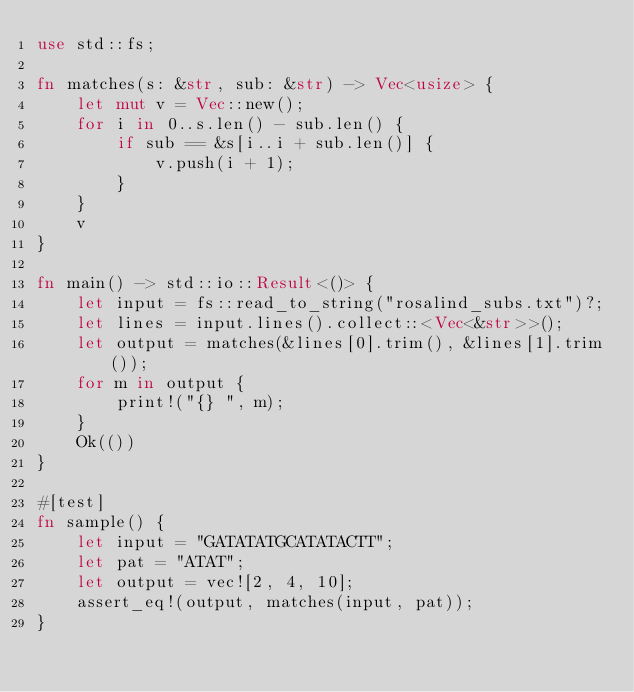<code> <loc_0><loc_0><loc_500><loc_500><_Rust_>use std::fs;

fn matches(s: &str, sub: &str) -> Vec<usize> {
    let mut v = Vec::new();
    for i in 0..s.len() - sub.len() {
        if sub == &s[i..i + sub.len()] {
            v.push(i + 1);
        }
    }
    v
}

fn main() -> std::io::Result<()> {
    let input = fs::read_to_string("rosalind_subs.txt")?;
    let lines = input.lines().collect::<Vec<&str>>();
    let output = matches(&lines[0].trim(), &lines[1].trim());
    for m in output {
        print!("{} ", m);
    }
    Ok(())
}

#[test]
fn sample() {
    let input = "GATATATGCATATACTT";
    let pat = "ATAT";
    let output = vec![2, 4, 10];
    assert_eq!(output, matches(input, pat));
}
</code> 